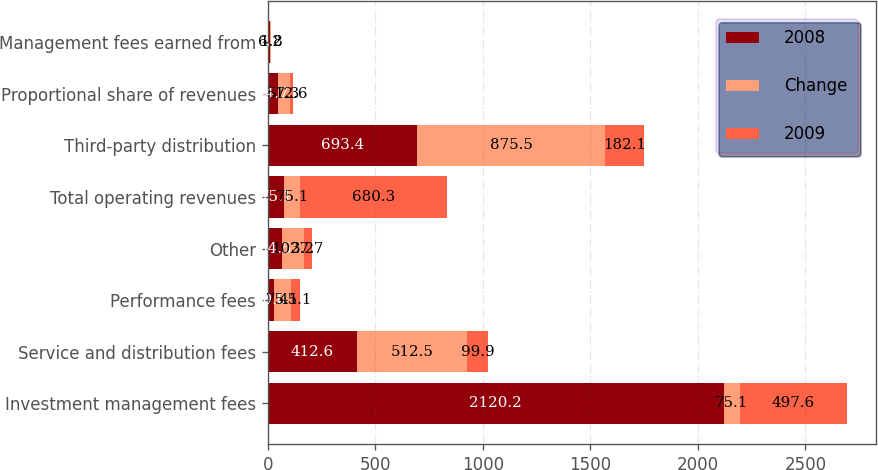<chart> <loc_0><loc_0><loc_500><loc_500><stacked_bar_chart><ecel><fcel>Investment management fees<fcel>Service and distribution fees<fcel>Performance fees<fcel>Other<fcel>Total operating revenues<fcel>Third-party distribution<fcel>Proportional share of revenues<fcel>Management fees earned from<nl><fcel>2008<fcel>2120.2<fcel>412.6<fcel>30<fcel>64.5<fcel>75.1<fcel>693.4<fcel>44.7<fcel>8<nl><fcel>Change<fcel>75.1<fcel>512.5<fcel>75.1<fcel>102.2<fcel>75.1<fcel>875.5<fcel>57.3<fcel>6.2<nl><fcel>2009<fcel>497.6<fcel>99.9<fcel>45.1<fcel>37.7<fcel>680.3<fcel>182.1<fcel>12.6<fcel>1.8<nl></chart> 